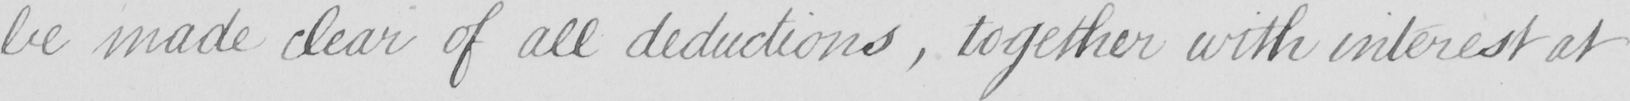Can you tell me what this handwritten text says? be made clear of all deductions  , together with interest at 